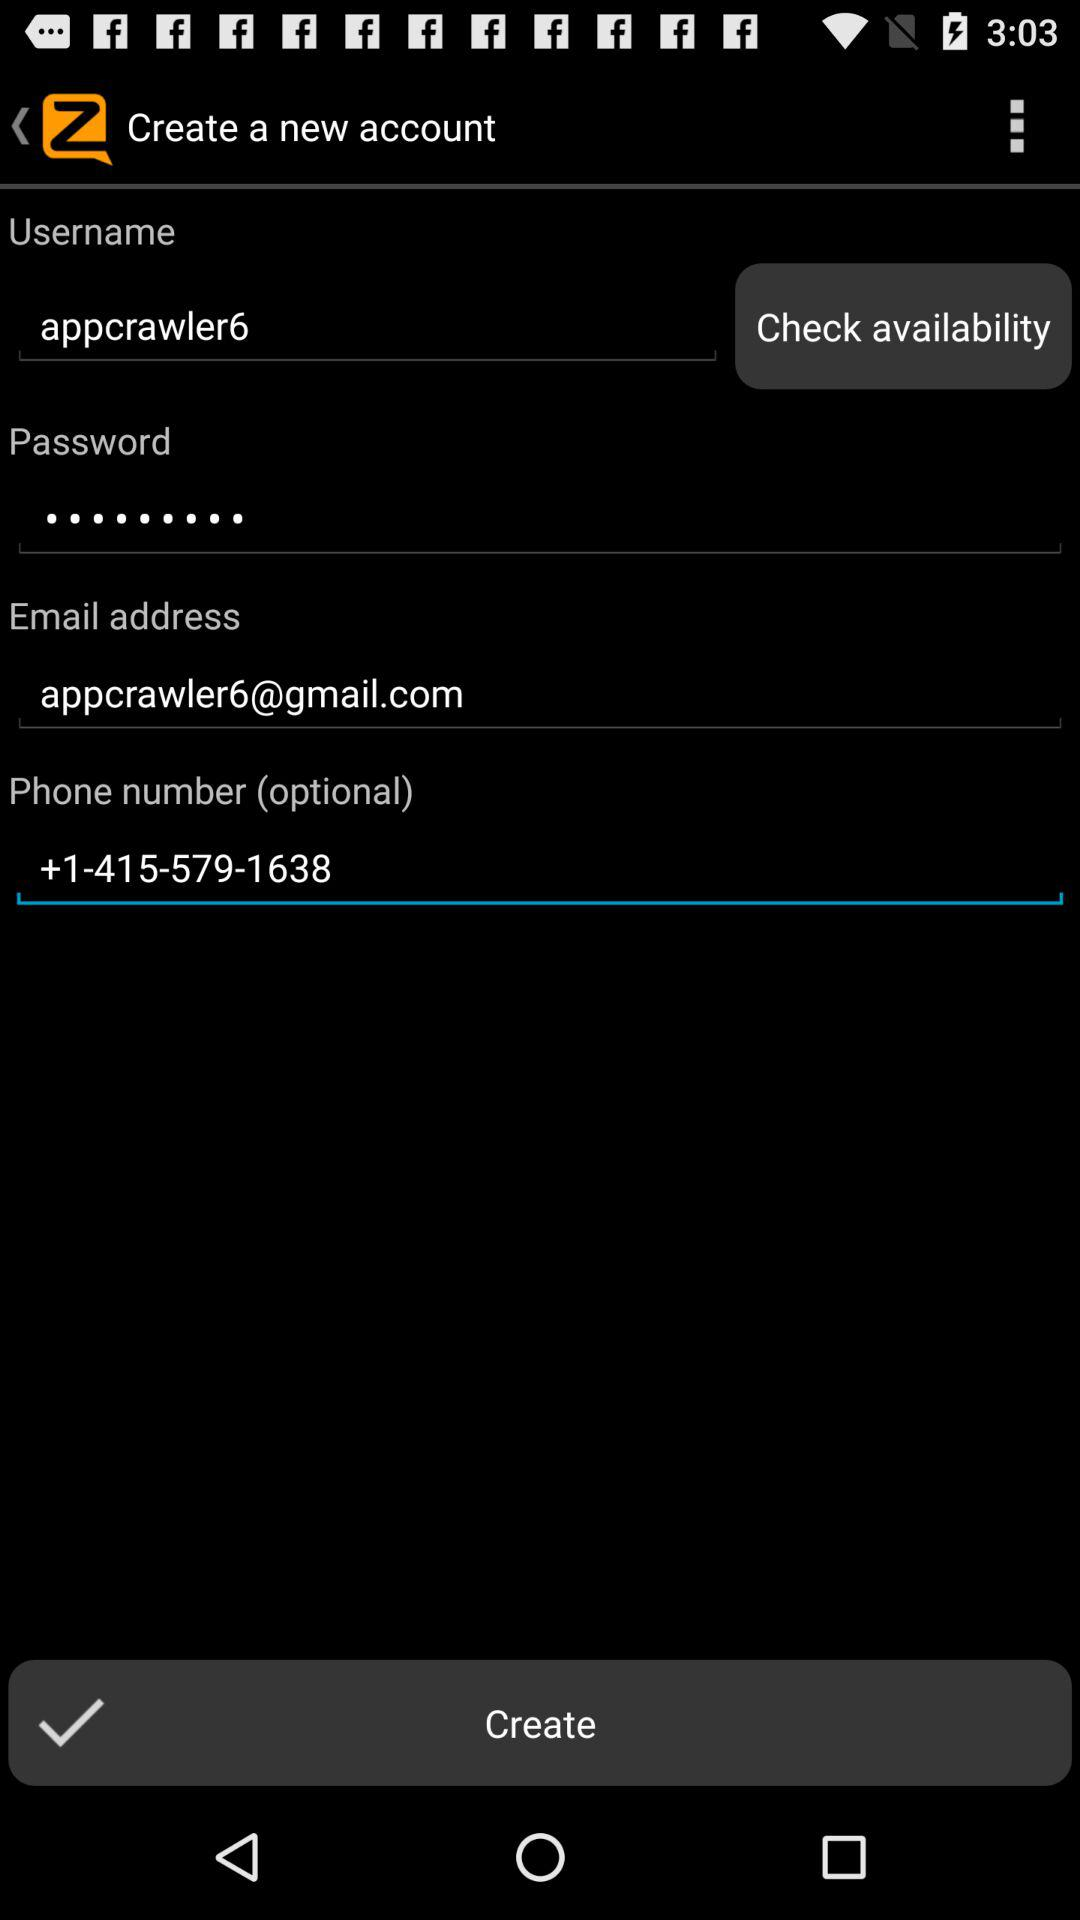What is the phone number? The phone number is +1-415-579-1638. 